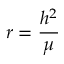Convert formula to latex. <formula><loc_0><loc_0><loc_500><loc_500>r = { \frac { h ^ { 2 } } { \mu } }</formula> 